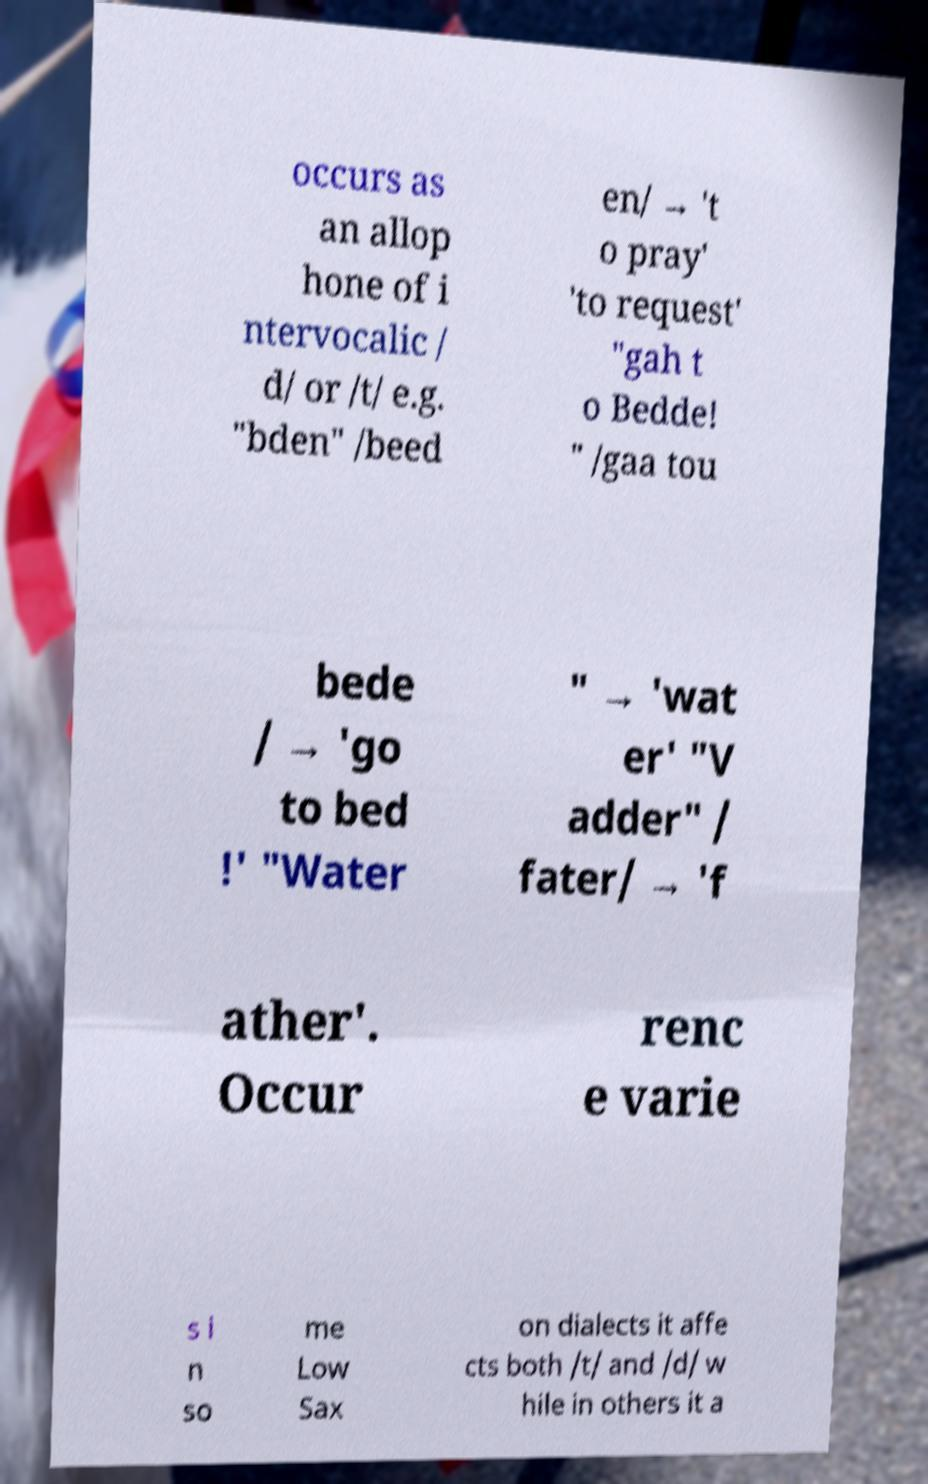Please identify and transcribe the text found in this image. occurs as an allop hone of i ntervocalic / d/ or /t/ e.g. "bden" /beed en/ → 't o pray' 'to request' "gah t o Bedde! " /gaa tou bede / → 'go to bed !' "Water " → 'wat er' "V adder" / fater/ → 'f ather'. Occur renc e varie s i n so me Low Sax on dialects it affe cts both /t/ and /d/ w hile in others it a 